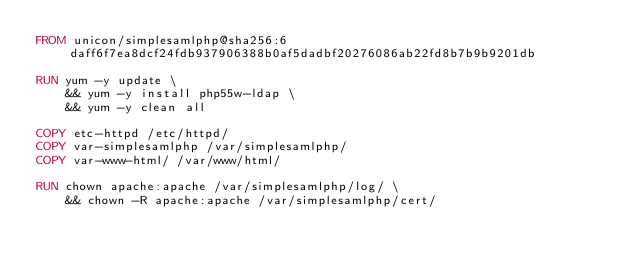<code> <loc_0><loc_0><loc_500><loc_500><_Dockerfile_>FROM unicon/simplesamlphp@sha256:6daff6f7ea8dcf24fdb937906388b0af5dadbf20276086ab22fd8b7b9b9201db

RUN yum -y update \
    && yum -y install php55w-ldap \
    && yum -y clean all

COPY etc-httpd /etc/httpd/
COPY var-simplesamlphp /var/simplesamlphp/
COPY var-www-html/ /var/www/html/

RUN chown apache:apache /var/simplesamlphp/log/ \
    && chown -R apache:apache /var/simplesamlphp/cert/
</code> 